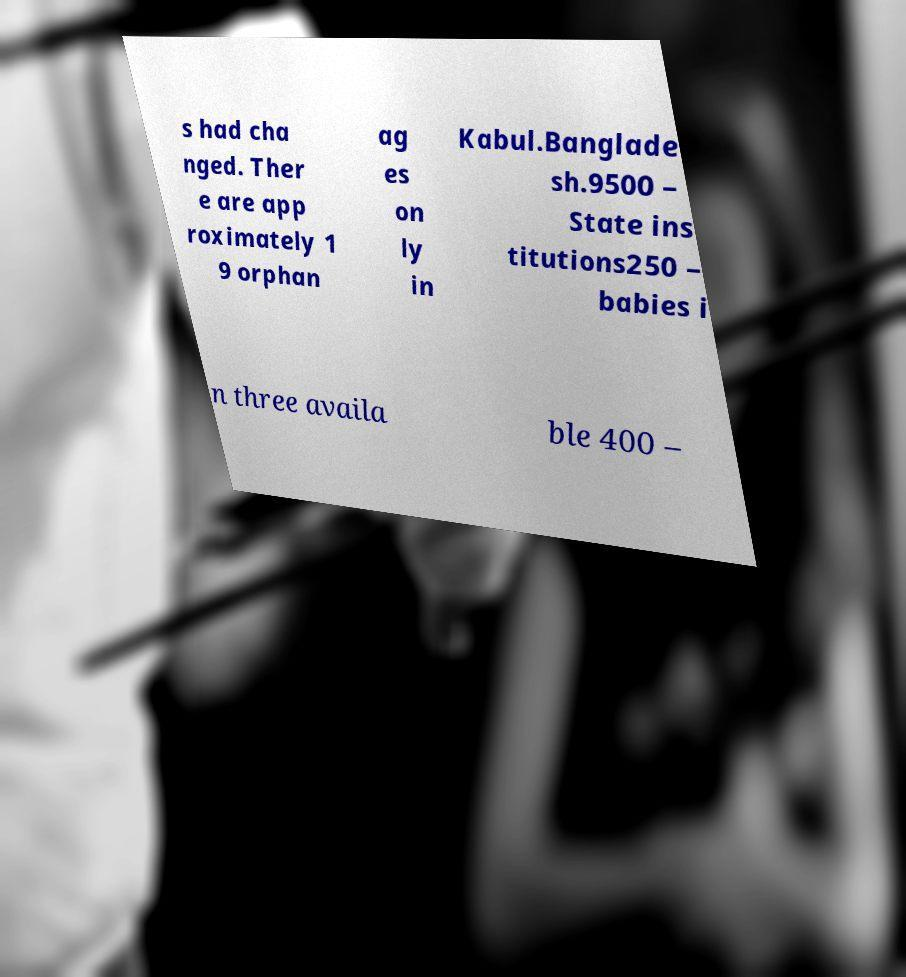I need the written content from this picture converted into text. Can you do that? s had cha nged. Ther e are app roximately 1 9 orphan ag es on ly in Kabul.Banglade sh.9500 – State ins titutions250 – babies i n three availa ble 400 – 